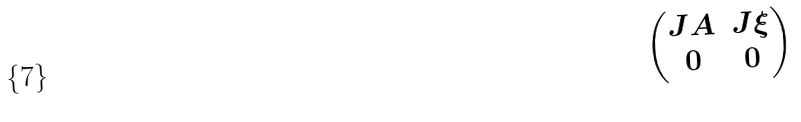<formula> <loc_0><loc_0><loc_500><loc_500>\begin{pmatrix} J A & J \xi \\ 0 & 0 \end{pmatrix}</formula> 